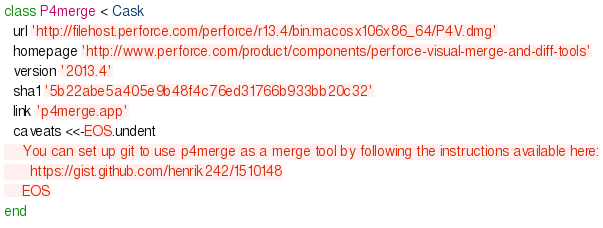Convert code to text. <code><loc_0><loc_0><loc_500><loc_500><_Ruby_>class P4merge < Cask
  url 'http://filehost.perforce.com/perforce/r13.4/bin.macosx106x86_64/P4V.dmg'
  homepage 'http://www.perforce.com/product/components/perforce-visual-merge-and-diff-tools'
  version '2013.4'
  sha1 '5b22abe5a405e9b48f4c76ed31766b933bb20c32'
  link 'p4merge.app'
  caveats <<-EOS.undent
    You can set up git to use p4merge as a merge tool by following the instructions available here:
      https://gist.github.com/henrik242/1510148
    EOS
end
</code> 